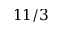<formula> <loc_0><loc_0><loc_500><loc_500>1 1 / 3</formula> 